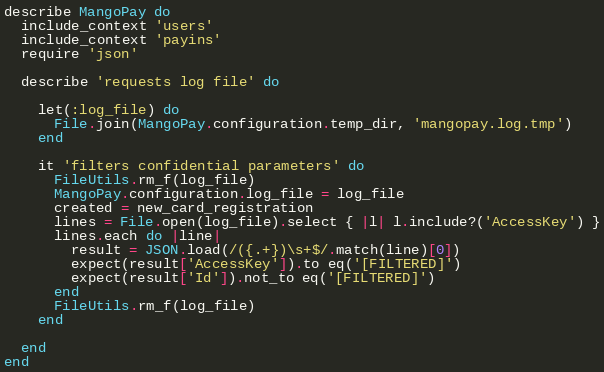<code> <loc_0><loc_0><loc_500><loc_500><_Ruby_>describe MangoPay do
  include_context 'users'
  include_context 'payins'
  require 'json'

  describe 'requests log file' do

    let(:log_file) do
      File.join(MangoPay.configuration.temp_dir, 'mangopay.log.tmp')
    end

    it 'filters confidential parameters' do
      FileUtils.rm_f(log_file)
      MangoPay.configuration.log_file = log_file
      created = new_card_registration
      lines = File.open(log_file).select { |l| l.include?('AccessKey') }
      lines.each do |line|
        result = JSON.load(/({.+})\s+$/.match(line)[0])
        expect(result['AccessKey']).to eq('[FILTERED]')
        expect(result['Id']).not_to eq('[FILTERED]')
      end
      FileUtils.rm_f(log_file)
    end

  end
end
</code> 